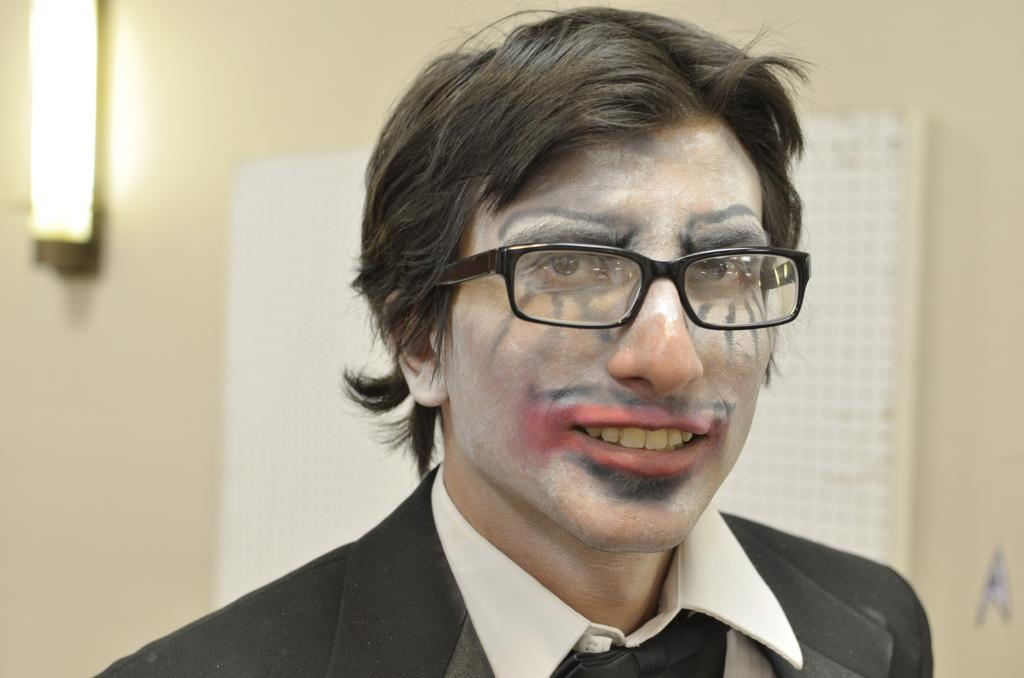Who is present in the image? There is a man in the image. What is the man wearing in the image? The man is wearing spectacles in the image. What can be seen in the background of the image? There is a light and a board on the wall in the background of the image. What type of event is taking place in the image involving a toad? There is no event or toad present in the image; it features a man wearing spectacles with a light and a board on the wall in the background. 